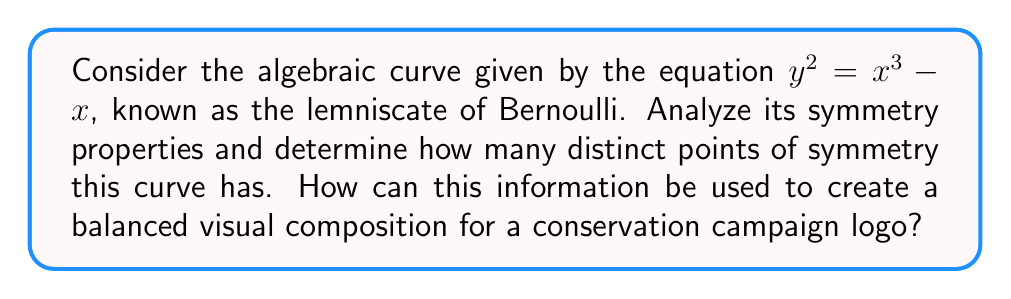Can you solve this math problem? Let's analyze the symmetry properties of the lemniscate of Bernoulli step by step:

1. Equation analysis:
   The curve is defined by $y^2 = x^3 - x$

2. Reflection symmetry about y-axis:
   Replace x with -x: $y^2 = (-x)^3 - (-x) = -x^3 + x$
   This is not equivalent to the original equation, so there's no reflection symmetry about the y-axis.

3. Reflection symmetry about x-axis:
   Replace y with -y: $(-y)^2 = x^3 - x$
   $y^2 = x^3 - x$
   This is equivalent to the original equation, so there's reflection symmetry about the x-axis.

4. Origin symmetry:
   Replace x with -x and y with -y: $(-y)^2 = (-x)^3 - (-x)$
   $y^2 = -x^3 + x$
   This is equivalent to the original equation, so there's rotational symmetry of order 2 about the origin.

5. Points of symmetry:
   - The origin (0,0) is a point of symmetry due to the rotational symmetry.
   - The point (1,0) is a point of symmetry as it lies on the curve and the x-axis.
   - The point (-1,0) is also a point of symmetry for the same reason.

Therefore, there are 3 distinct points of symmetry.

To use this information in creating a balanced visual composition for a conservation campaign logo:

1. The three points of symmetry can represent three key aspects of conservation (e.g., land, water, and air).
2. The x-axis symmetry can be used to create a mirrored design, symbolizing balance in nature.
3. The overall shape of the lemniscate (figure-eight) can represent infinity or the cyclical nature of ecosystems.

[asy]
import graph;
size(200);
real f(real x) {return sqrt(x^3 - x);}
draw(graph(f, -sqrt(2/3), sqrt(2/3)), blue);
draw(graph(-f, -sqrt(2/3), sqrt(2/3)), blue);
draw((-2,0)--(2,0), arrow=Arrow(TeXHead));
draw((0,-1.5)--(0,1.5), arrow=Arrow(TeXHead));
dot((0,0));
dot((1,0));
dot((-1,0));
label("(0,0)", (0,0), SE);
label("(1,0)", (1,0), N);
label("(-1,0)", (-1,0), N);
[/asy]
Answer: 3 points of symmetry 